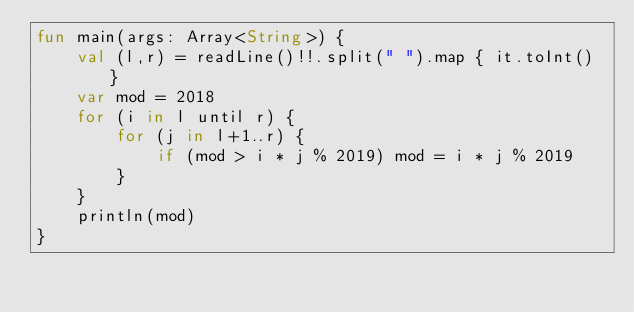Convert code to text. <code><loc_0><loc_0><loc_500><loc_500><_Kotlin_>fun main(args: Array<String>) {
    val (l,r) = readLine()!!.split(" ").map { it.toInt() }
    var mod = 2018
    for (i in l until r) {
        for (j in l+1..r) {
            if (mod > i * j % 2019) mod = i * j % 2019
        }
    }
    println(mod)
}</code> 